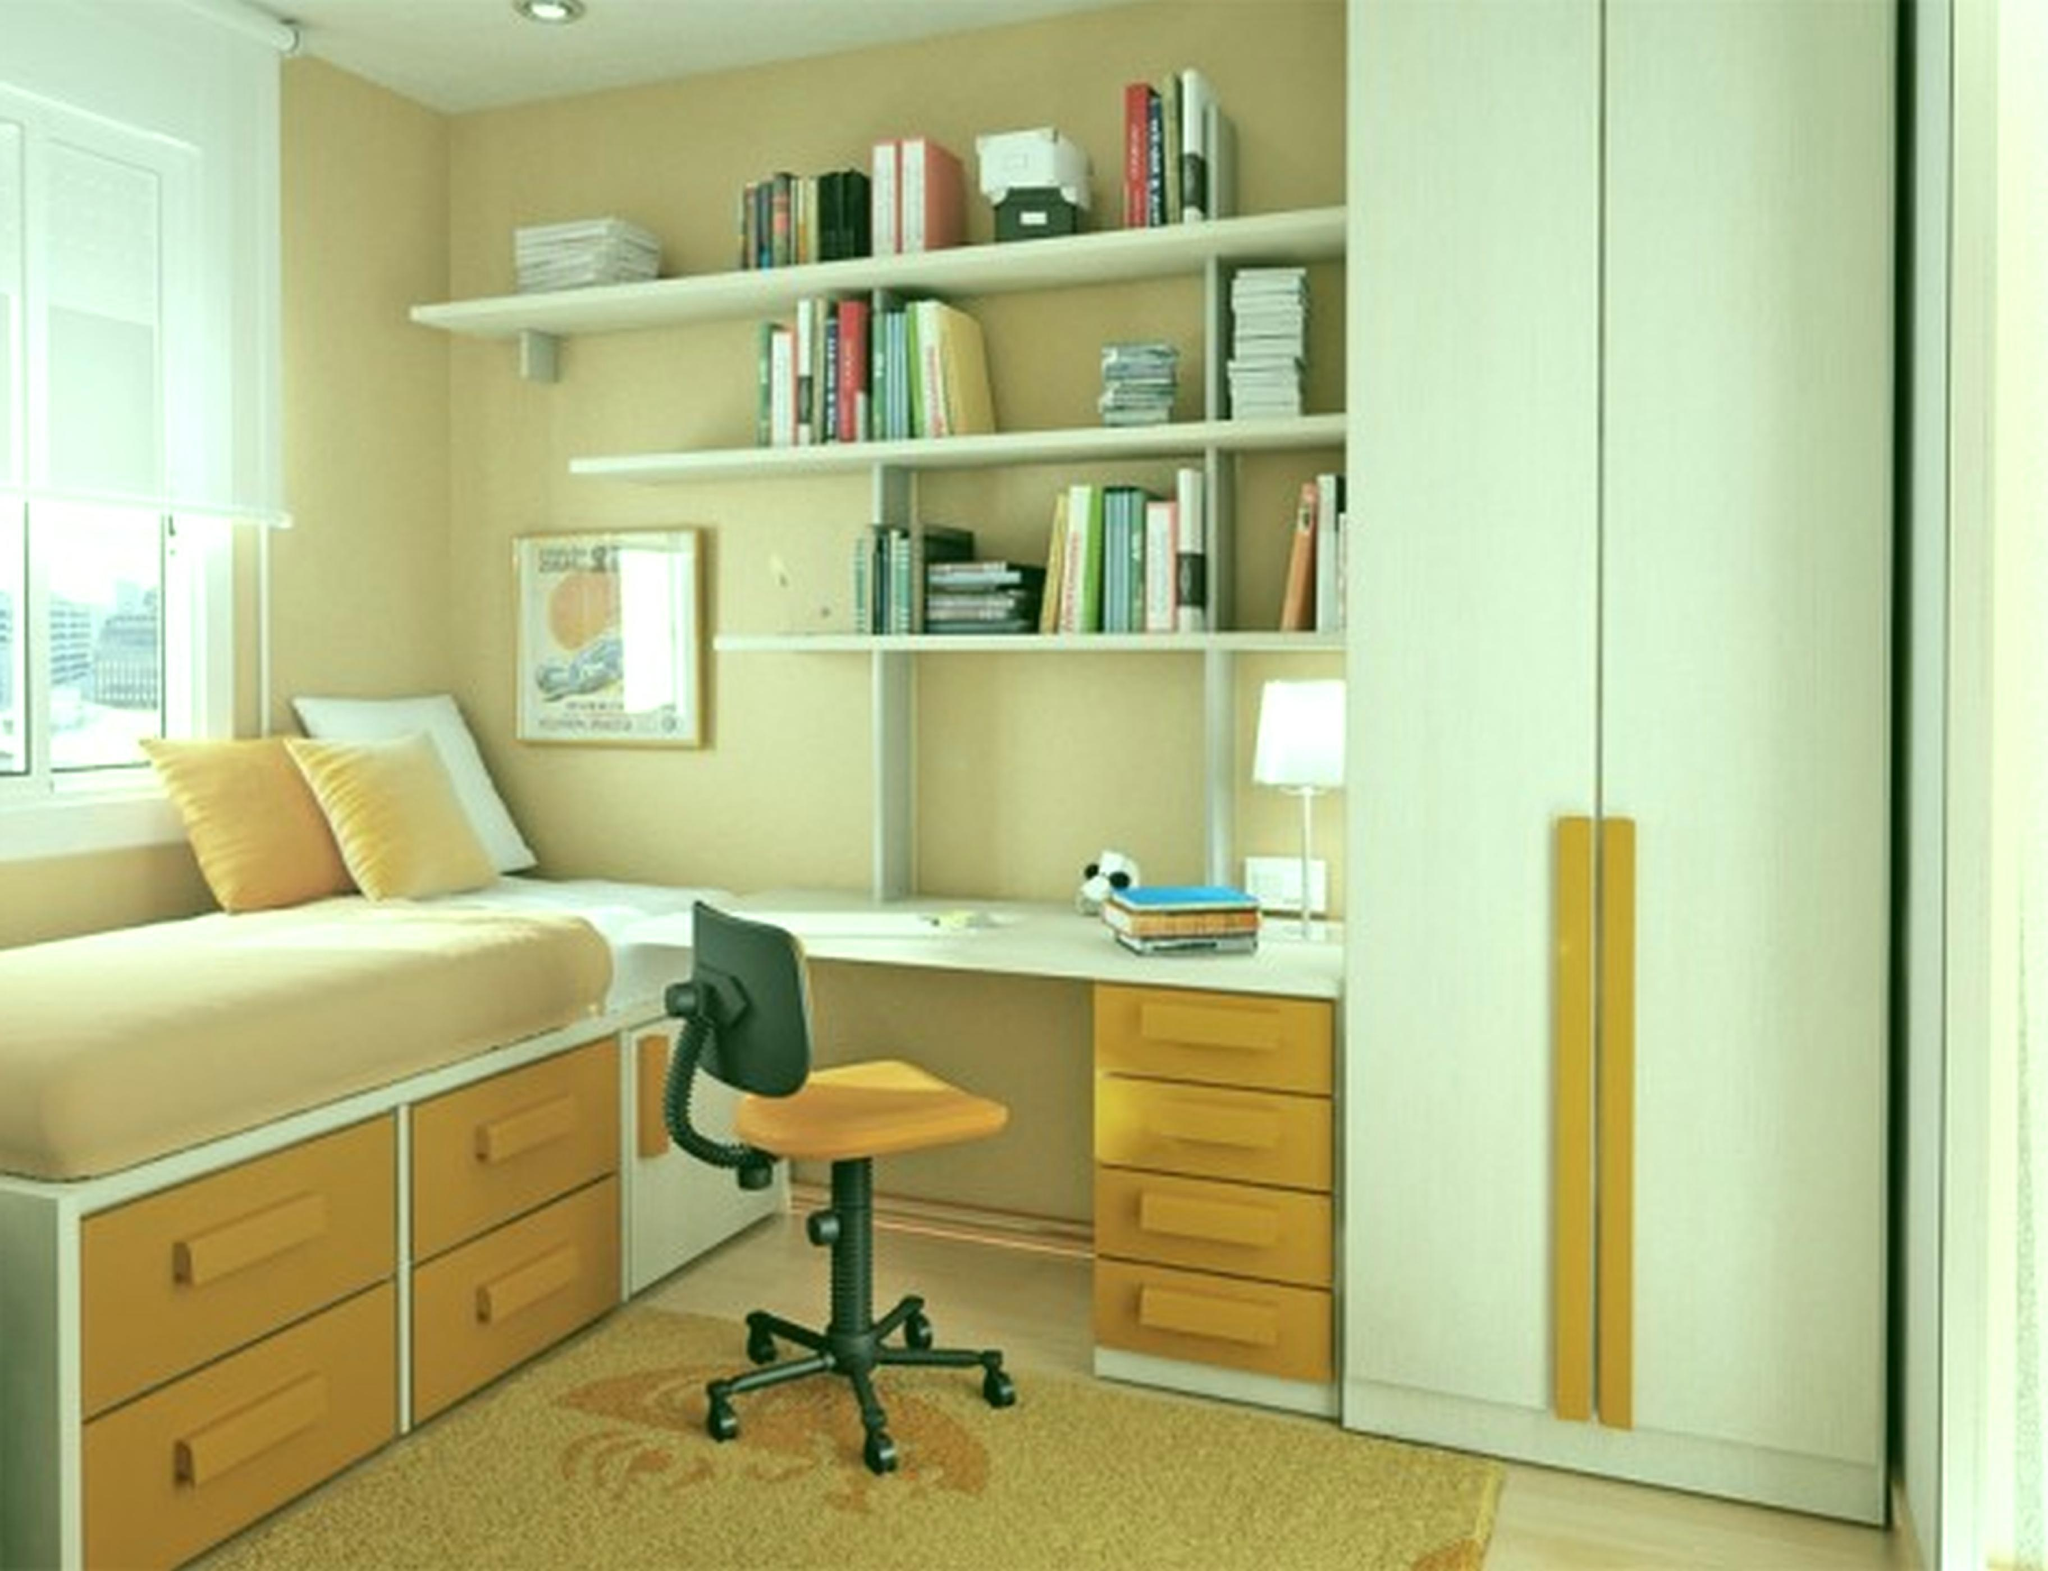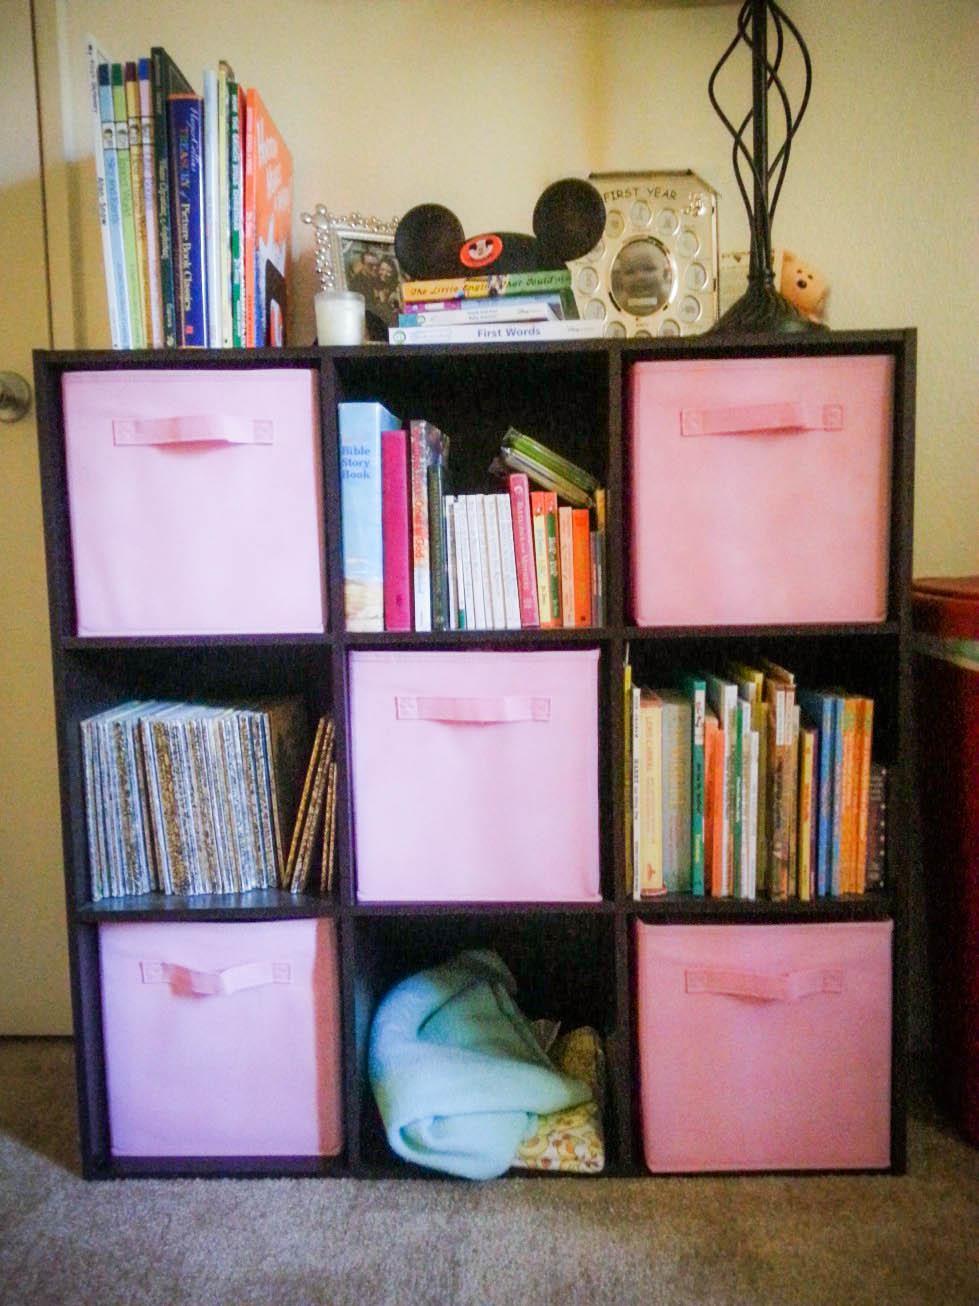The first image is the image on the left, the second image is the image on the right. For the images shown, is this caption "At least three pillows are in a window seat in one of the images." true? Answer yes or no. Yes. The first image is the image on the left, the second image is the image on the right. For the images displayed, is the sentence "There is an office chair in front of a desk that has four drawers." factually correct? Answer yes or no. Yes. 